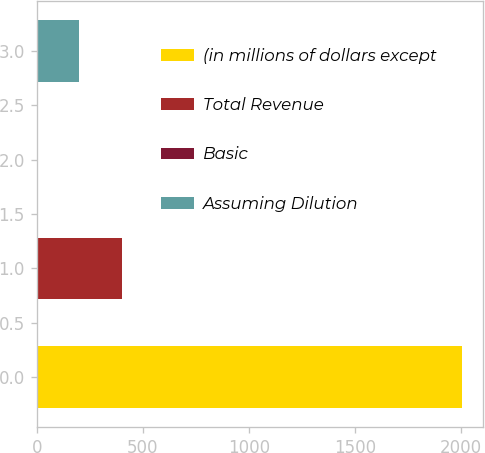Convert chart to OTSL. <chart><loc_0><loc_0><loc_500><loc_500><bar_chart><fcel>(in millions of dollars except<fcel>Total Revenue<fcel>Basic<fcel>Assuming Dilution<nl><fcel>2005<fcel>401.03<fcel>0.03<fcel>200.53<nl></chart> 